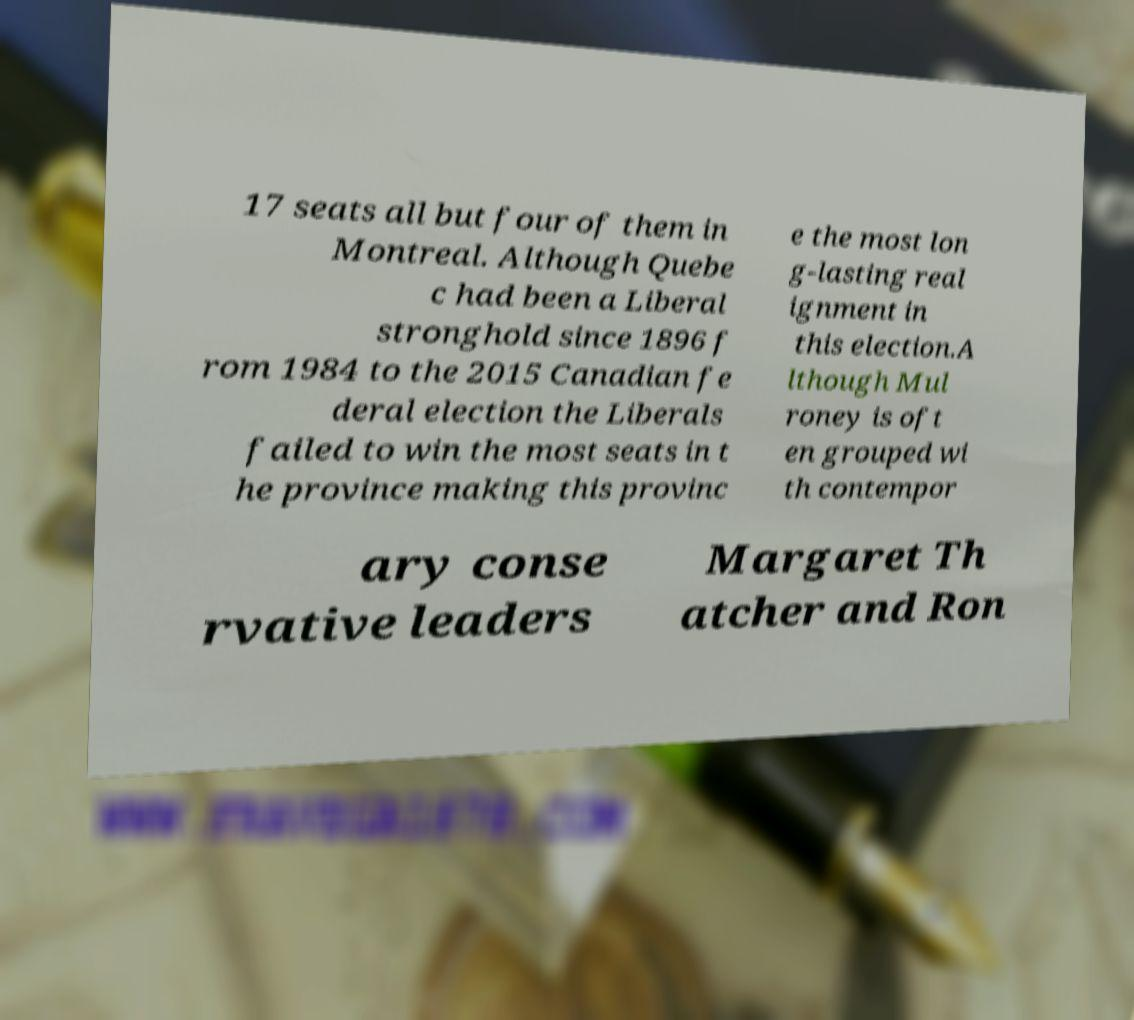I need the written content from this picture converted into text. Can you do that? 17 seats all but four of them in Montreal. Although Quebe c had been a Liberal stronghold since 1896 f rom 1984 to the 2015 Canadian fe deral election the Liberals failed to win the most seats in t he province making this provinc e the most lon g-lasting real ignment in this election.A lthough Mul roney is oft en grouped wi th contempor ary conse rvative leaders Margaret Th atcher and Ron 